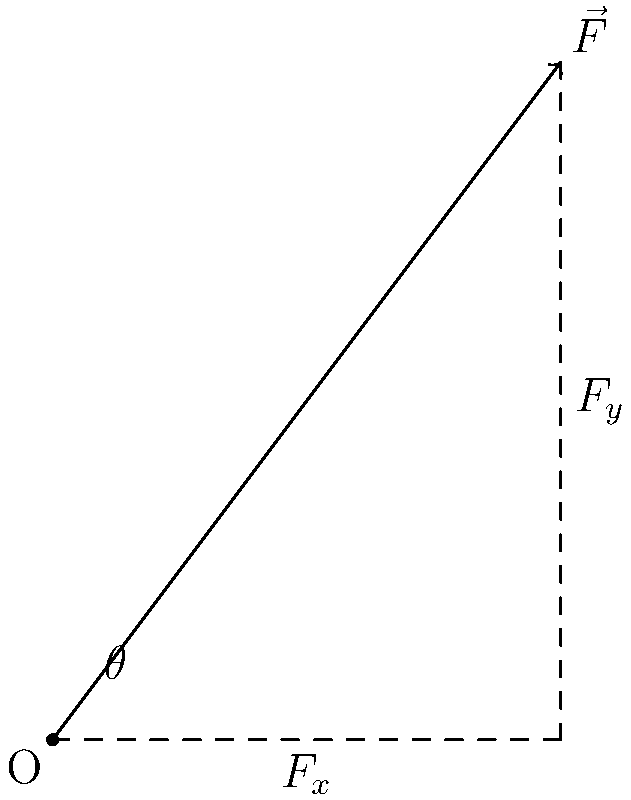An archer draws a bowstring with a force $\vec{F}$ of magnitude 50 N at an angle of 53° above the horizontal. Inspired by Matthew Tauiliili's precise technique, you want to calculate the horizontal component of this force. What is the magnitude of the horizontal component $F_x$ in Newtons? To find the horizontal component of the force, we can follow these steps:

1) The horizontal component of a vector is given by the formula:
   $$F_x = |\vec{F}| \cos(\theta)$$
   Where $|\vec{F}|$ is the magnitude of the force and $\theta$ is the angle from the horizontal.

2) We are given:
   $$|\vec{F}| = 50 \text{ N}$$
   $$\theta = 53°$$

3) Substituting these values into our formula:
   $$F_x = 50 \cos(53°)$$

4) Using a calculator or trigonometric tables:
   $$\cos(53°) \approx 0.6018$$

5) Therefore:
   $$F_x = 50 \times 0.6018 = 30.09 \text{ N}$$

6) Rounding to two decimal places:
   $$F_x \approx 30.09 \text{ N}$$
Answer: 30.09 N 